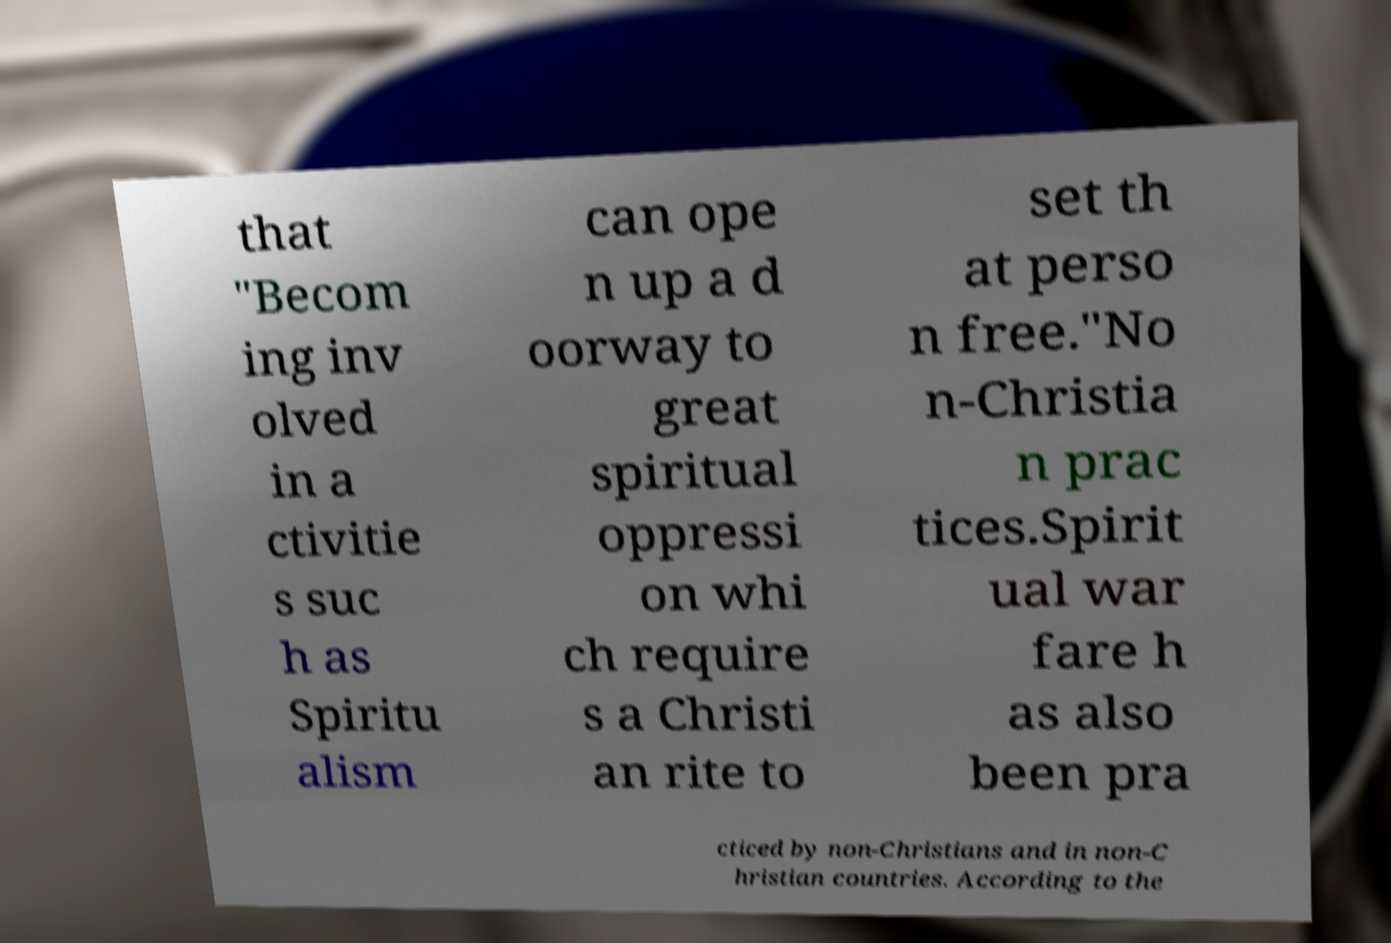Can you accurately transcribe the text from the provided image for me? that "Becom ing inv olved in a ctivitie s suc h as Spiritu alism can ope n up a d oorway to great spiritual oppressi on whi ch require s a Christi an rite to set th at perso n free."No n-Christia n prac tices.Spirit ual war fare h as also been pra cticed by non-Christians and in non-C hristian countries. According to the 